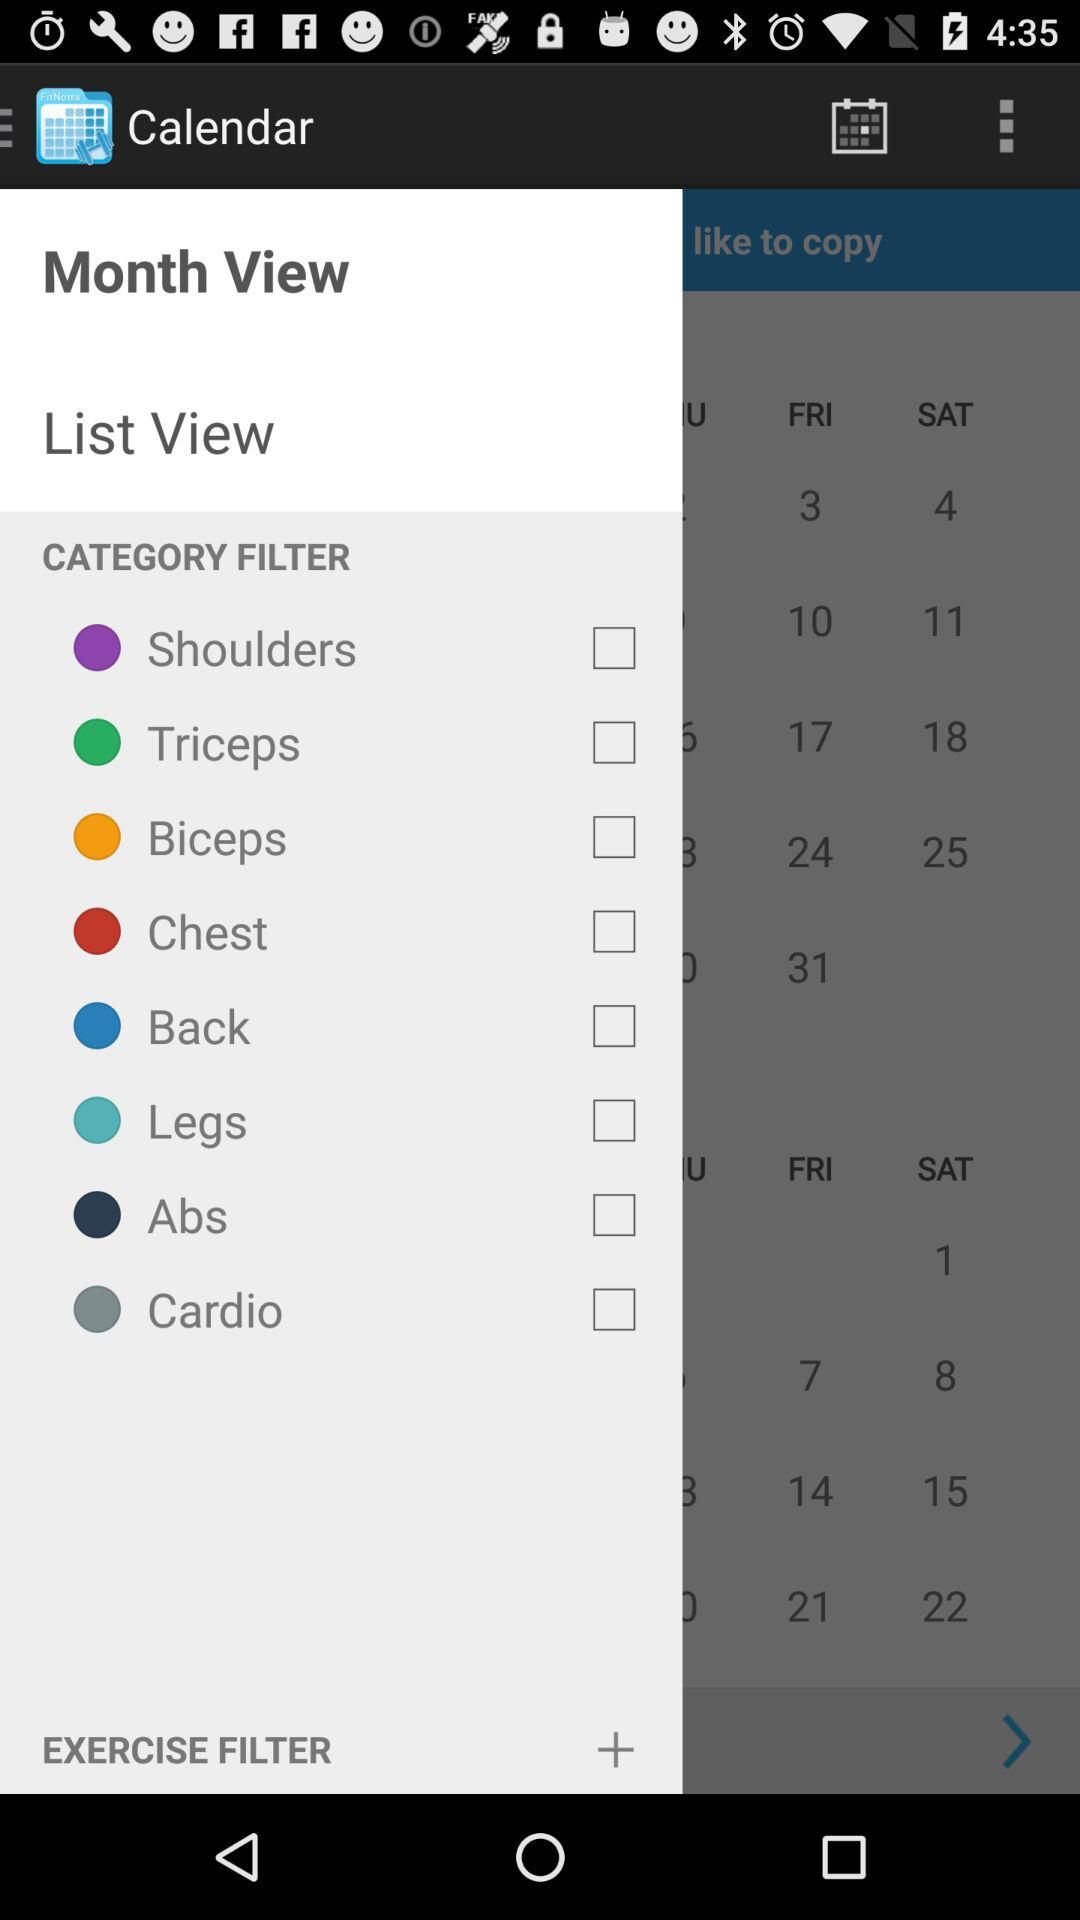What are the different category filters available? The different category filters available are "Shoulders", "Triceps", "Biceps", "Chest", "Back", "Legs", "Abs" and "Cardio". 